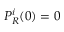<formula> <loc_0><loc_0><loc_500><loc_500>P _ { R } ^ { i } ( 0 ) = 0</formula> 